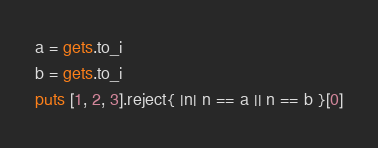<code> <loc_0><loc_0><loc_500><loc_500><_Ruby_>a = gets.to_i
b = gets.to_i
puts [1, 2, 3].reject{ |n| n == a || n == b }[0]</code> 